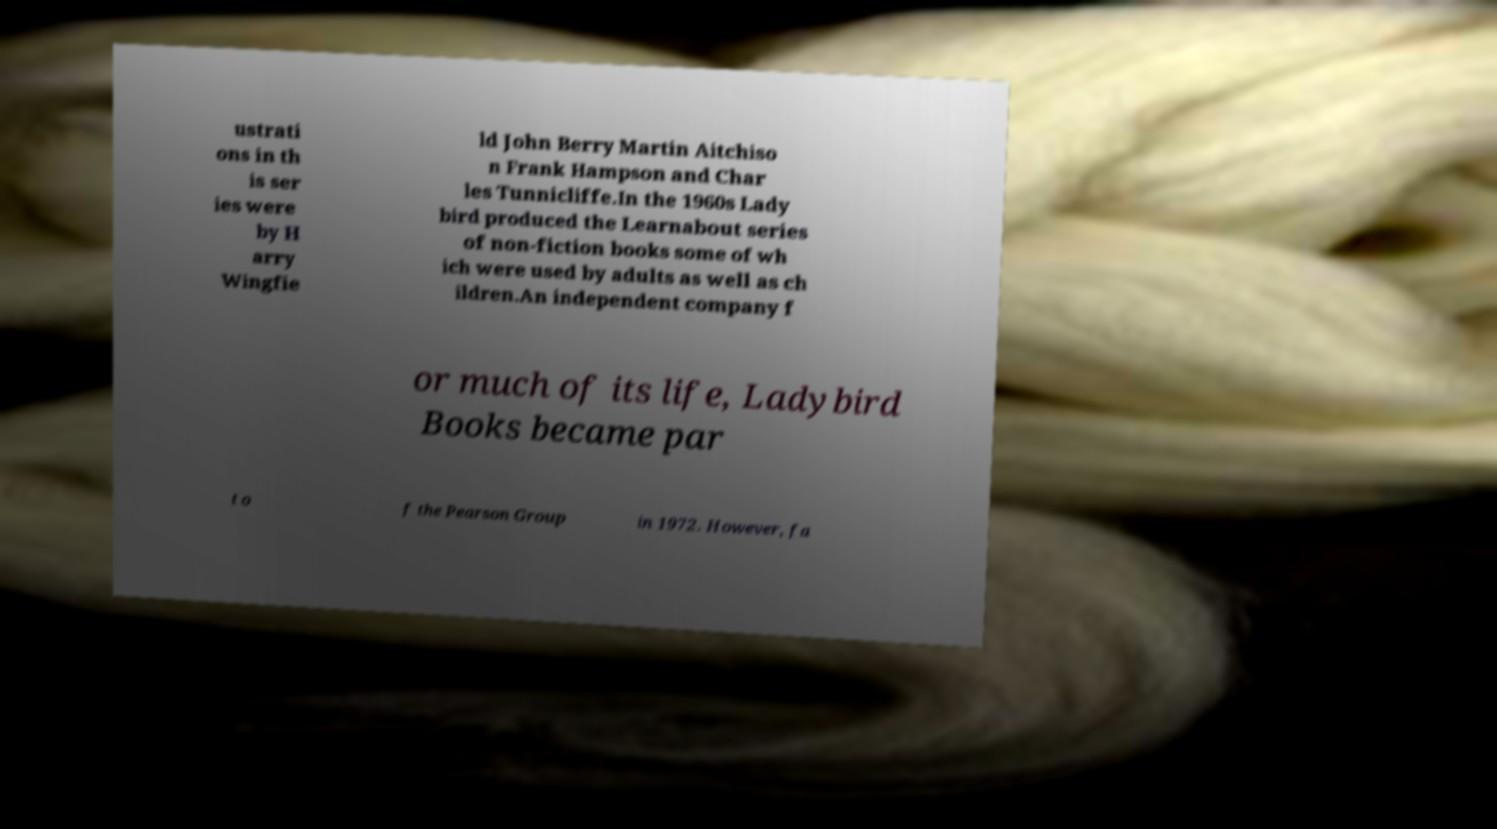Can you read and provide the text displayed in the image?This photo seems to have some interesting text. Can you extract and type it out for me? ustrati ons in th is ser ies were by H arry Wingfie ld John Berry Martin Aitchiso n Frank Hampson and Char les Tunnicliffe.In the 1960s Lady bird produced the Learnabout series of non-fiction books some of wh ich were used by adults as well as ch ildren.An independent company f or much of its life, Ladybird Books became par t o f the Pearson Group in 1972. However, fa 